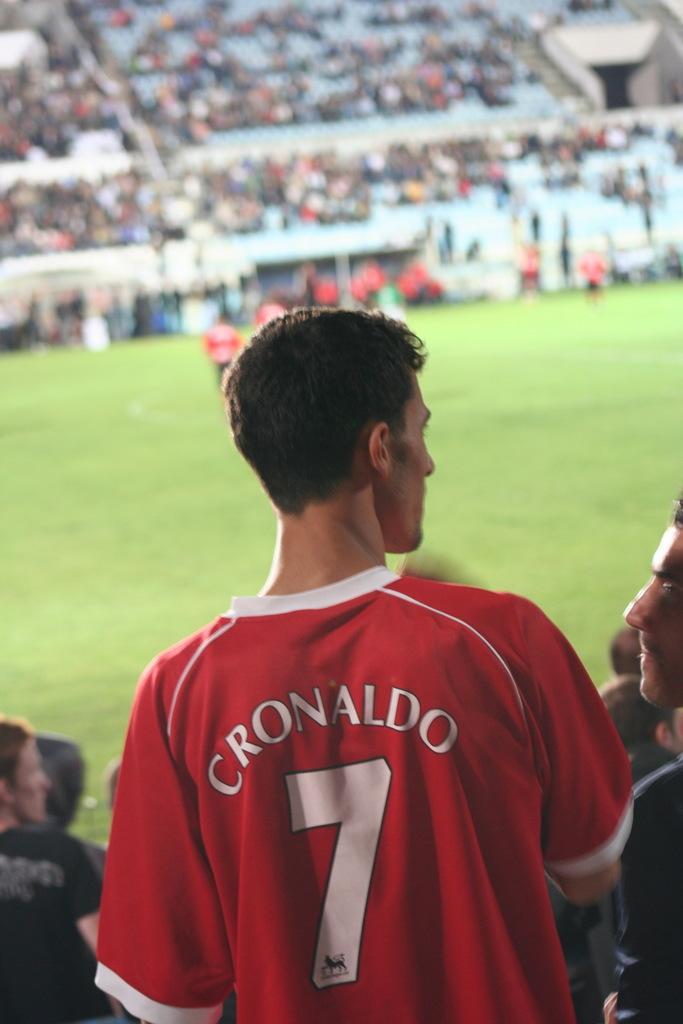<image>
Give a short and clear explanation of the subsequent image. A man wearing a red jersey with the number 7 on it is in the stands of a sporting event. 